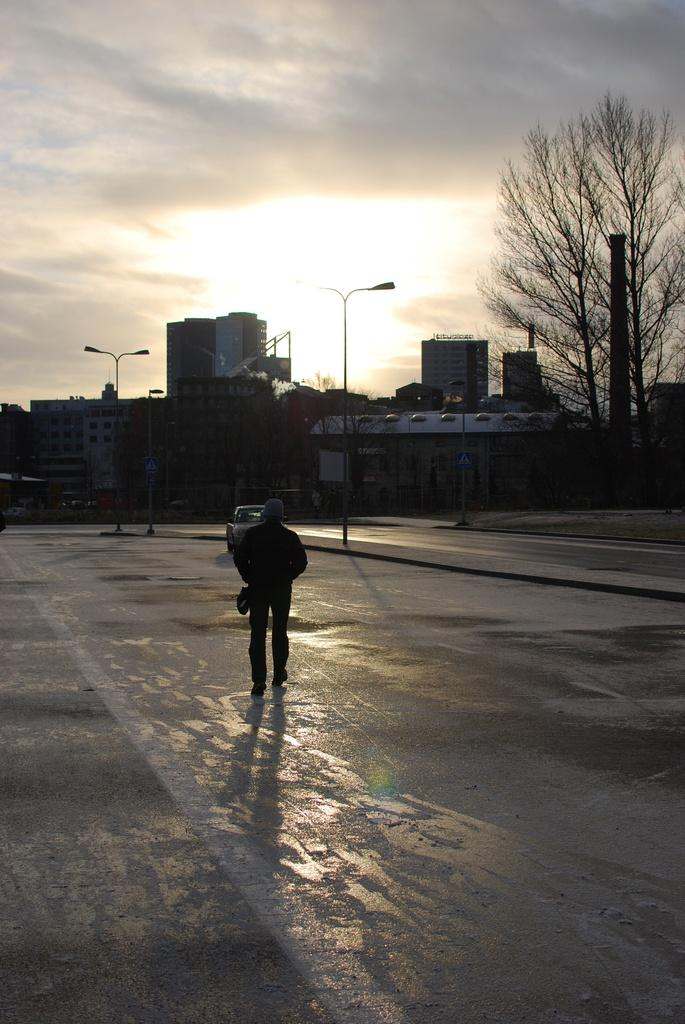What is the person in the image doing? There is a person walking in the image. What else can be seen on the road in the image? There is a vehicle on the road in the image. What type of natural elements are present in the image? Trees are present in the image. What type of man-made structures can be seen in the image? There are buildings in the image. What is visible in the background of the image? The sky with clouds is visible in the background of the image. How many chairs can be seen in the image? There are no chairs present in the image. 